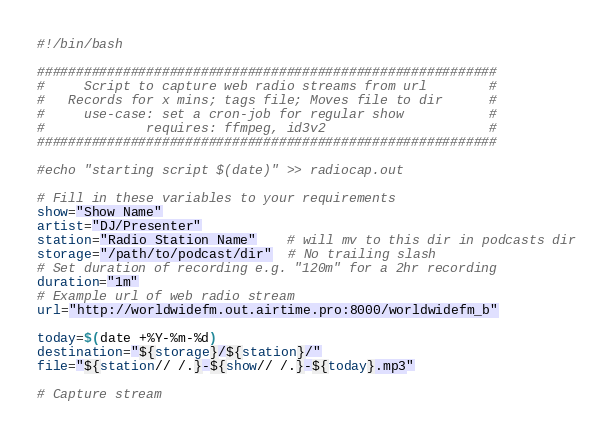Convert code to text. <code><loc_0><loc_0><loc_500><loc_500><_Bash_>#!/bin/bash

###########################################################
#     Script to capture web radio streams from url        #
#   Records for x mins; tags file; Moves file to dir      #
#     use-case: set a cron-job for regular show           #
#             requires: ffmpeg, id3v2                     #
###########################################################

#echo "starting script $(date)" >> radiocap.out

# Fill in these variables to your requirements
show="Show Name"
artist="DJ/Presenter"
station="Radio Station Name"	# will mv to this dir in podcasts dir
storage="/path/to/podcast/dir"  # No trailing slash
# Set duration of recording e.g. "120m" for a 2hr recording
duration="1m"
# Example url of web radio stream
url="http://worldwidefm.out.airtime.pro:8000/worldwidefm_b"

today=$(date +%Y-%m-%d)
destination="${storage}/${station}/"
file="${station// /.}-${show// /.}-${today}.mp3"

# Capture stream</code> 